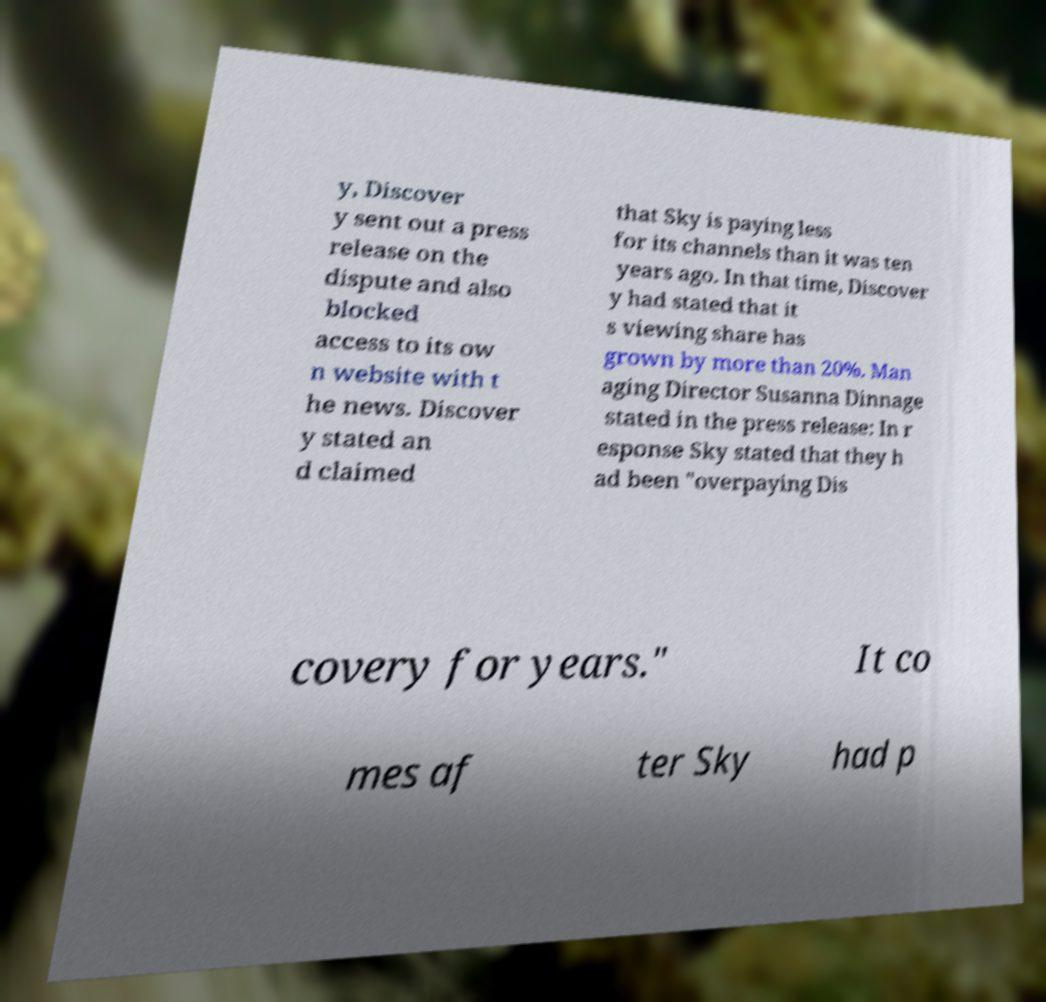There's text embedded in this image that I need extracted. Can you transcribe it verbatim? y, Discover y sent out a press release on the dispute and also blocked access to its ow n website with t he news. Discover y stated an d claimed that Sky is paying less for its channels than it was ten years ago. In that time, Discover y had stated that it s viewing share has grown by more than 20%. Man aging Director Susanna Dinnage stated in the press release: In r esponse Sky stated that they h ad been "overpaying Dis covery for years." It co mes af ter Sky had p 